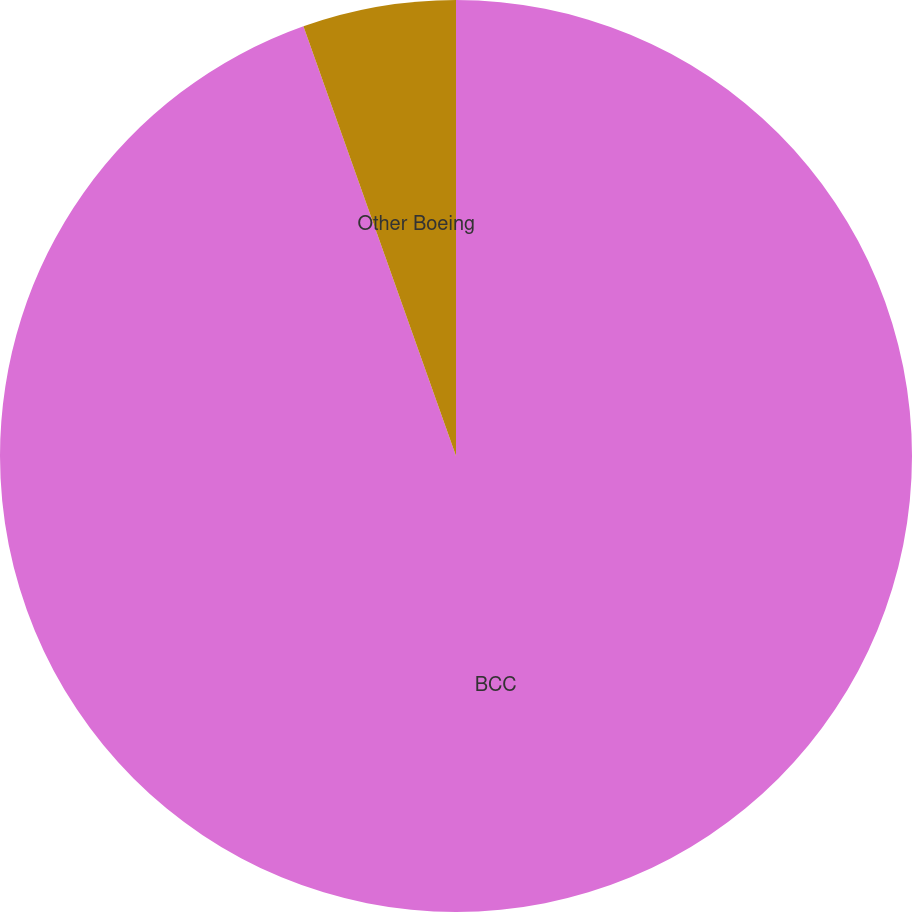<chart> <loc_0><loc_0><loc_500><loc_500><pie_chart><fcel>BCC<fcel>Other Boeing<nl><fcel>94.57%<fcel>5.43%<nl></chart> 